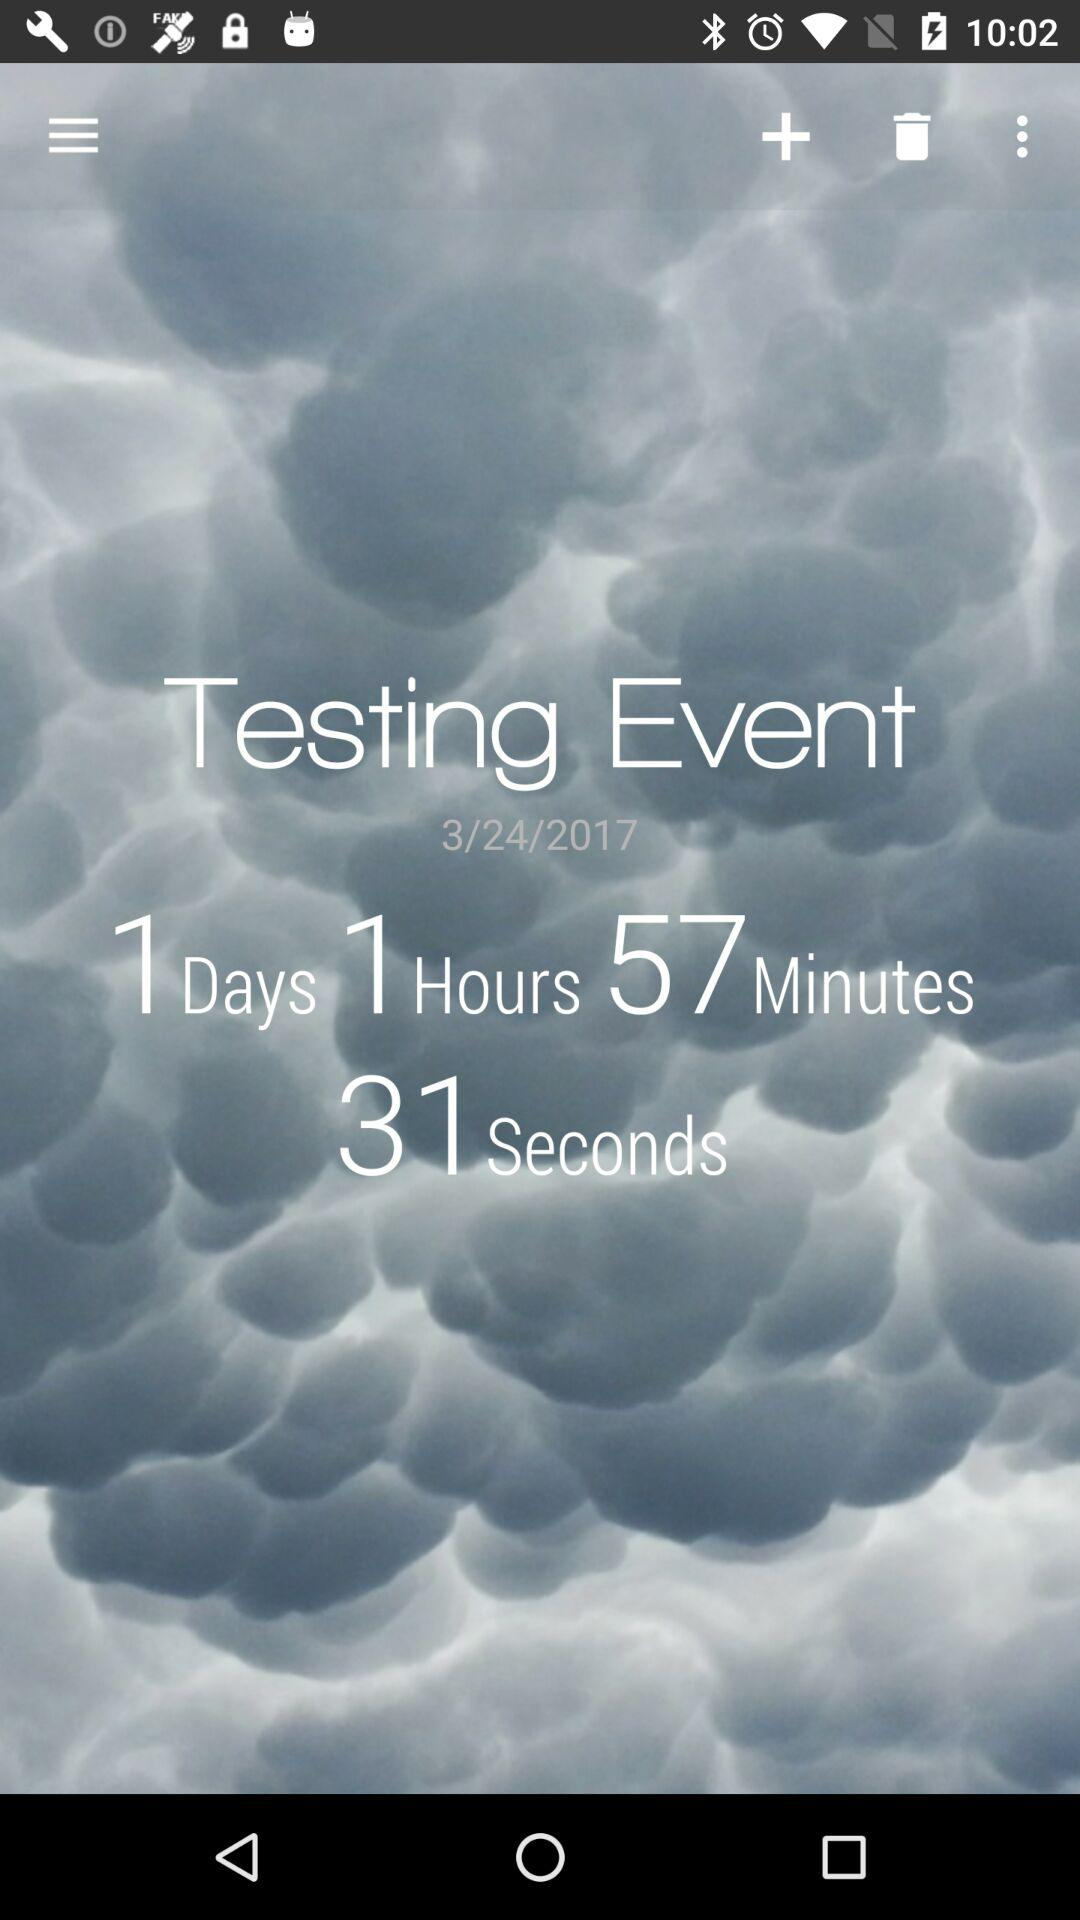How many seconds are there in the event?
Answer the question using a single word or phrase. 31 